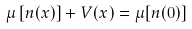Convert formula to latex. <formula><loc_0><loc_0><loc_500><loc_500>\mu \left [ n ( x ) \right ] + V ( x ) = \mu [ n ( 0 ) ]</formula> 